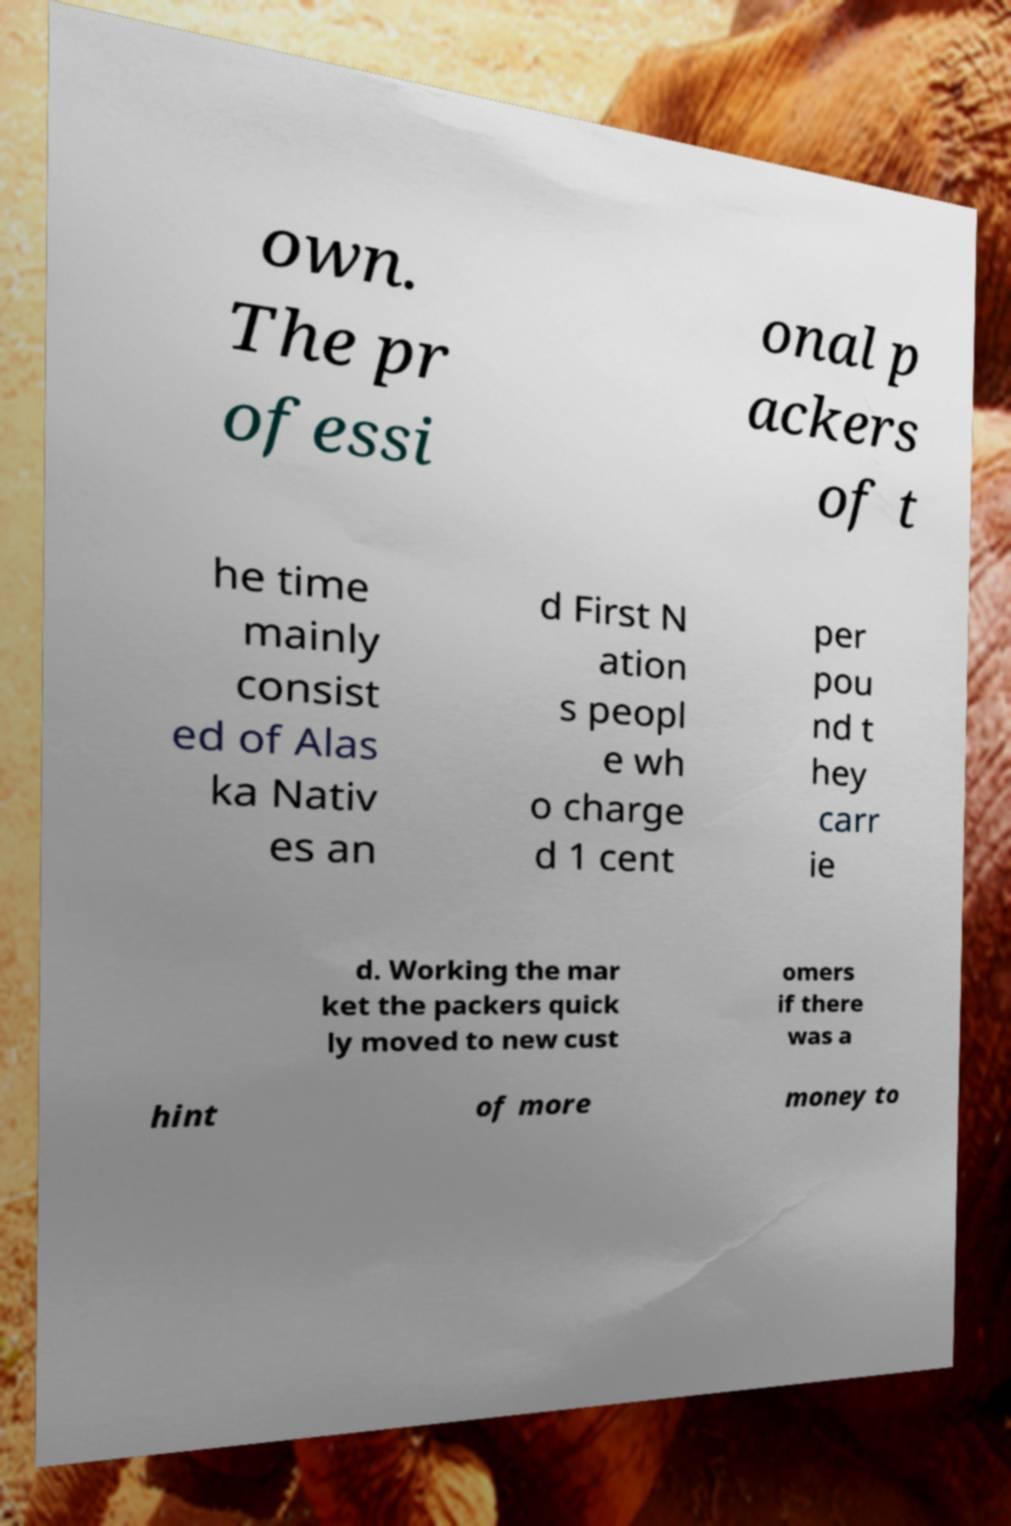I need the written content from this picture converted into text. Can you do that? own. The pr ofessi onal p ackers of t he time mainly consist ed of Alas ka Nativ es an d First N ation s peopl e wh o charge d 1 cent per pou nd t hey carr ie d. Working the mar ket the packers quick ly moved to new cust omers if there was a hint of more money to 